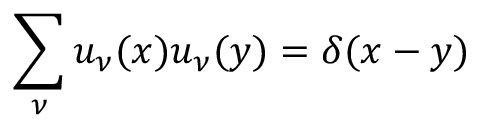<formula> <loc_0><loc_0><loc_500><loc_500>\sum _ { \nu } u _ { \nu } ( x ) u _ { \nu } ( y ) = \delta ( x - y )</formula> 